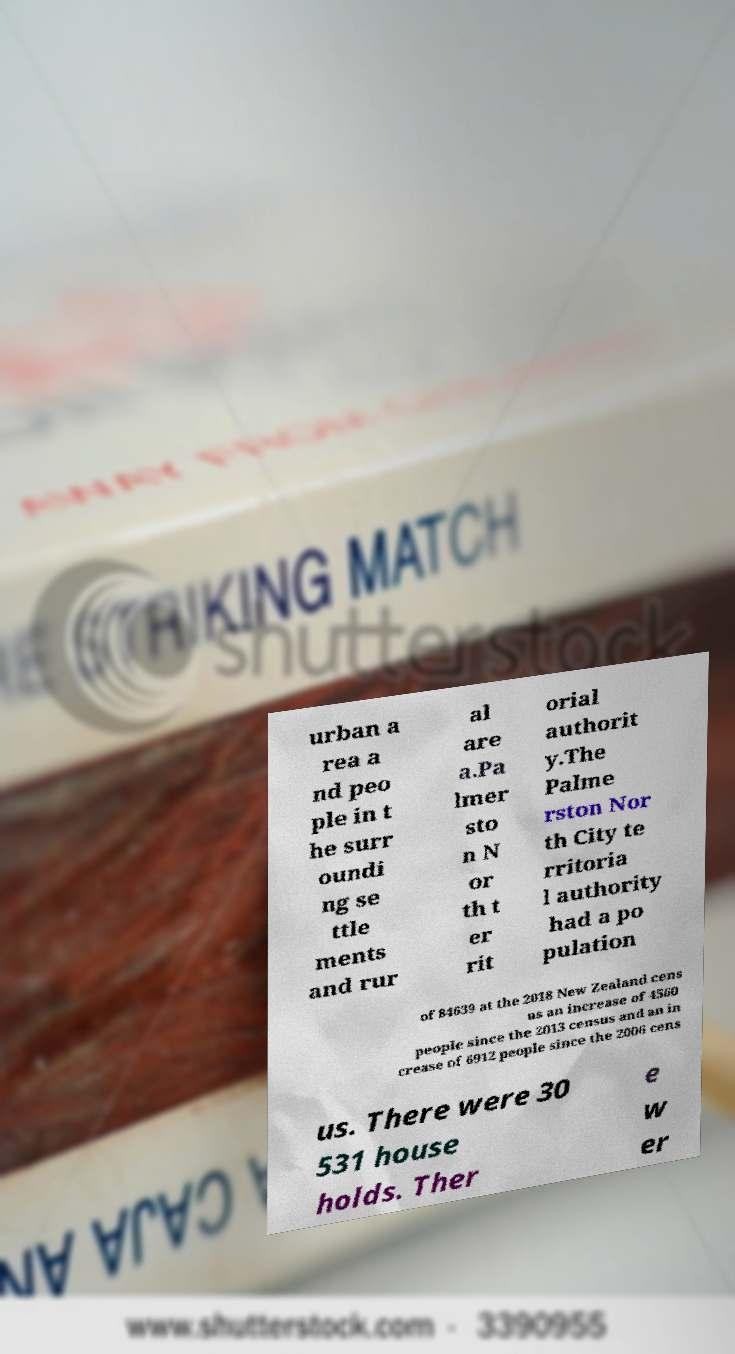I need the written content from this picture converted into text. Can you do that? urban a rea a nd peo ple in t he surr oundi ng se ttle ments and rur al are a.Pa lmer sto n N or th t er rit orial authorit y.The Palme rston Nor th City te rritoria l authority had a po pulation of 84639 at the 2018 New Zealand cens us an increase of 4560 people since the 2013 census and an in crease of 6912 people since the 2006 cens us. There were 30 531 house holds. Ther e w er 